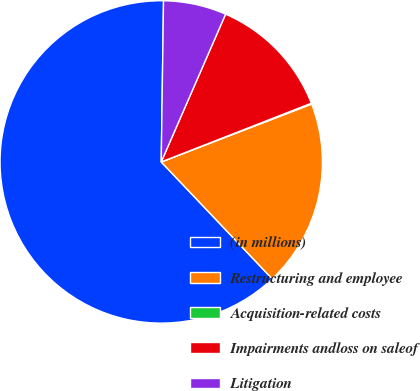Convert chart. <chart><loc_0><loc_0><loc_500><loc_500><pie_chart><fcel>(in millions)<fcel>Restructuring and employee<fcel>Acquisition-related costs<fcel>Impairments andloss on saleof<fcel>Litigation<nl><fcel>62.32%<fcel>18.76%<fcel>0.09%<fcel>12.53%<fcel>6.31%<nl></chart> 